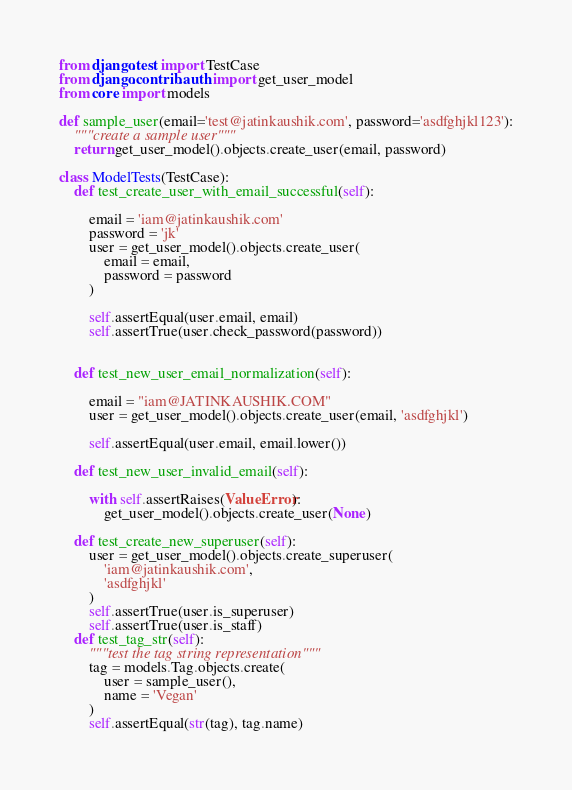<code> <loc_0><loc_0><loc_500><loc_500><_Python_>from django.test import TestCase
from django.contrib.auth import get_user_model
from core import models

def sample_user(email='test@jatinkaushik.com', password='asdfghjkl123'):
    """create a sample user"""
    return get_user_model().objects.create_user(email, password)

class ModelTests(TestCase):
    def test_create_user_with_email_successful(self):

        email = 'iam@jatinkaushik.com'
        password = 'jk'
        user = get_user_model().objects.create_user(
            email = email,
            password = password
        )

        self.assertEqual(user.email, email)
        self.assertTrue(user.check_password(password))


    def test_new_user_email_normalization(self):

        email = "iam@JATINKAUSHIK.COM"
        user = get_user_model().objects.create_user(email, 'asdfghjkl')

        self.assertEqual(user.email, email.lower())

    def test_new_user_invalid_email(self):

        with self.assertRaises(ValueError):
            get_user_model().objects.create_user(None)

    def test_create_new_superuser(self):
        user = get_user_model().objects.create_superuser(
            'iam@jatinkaushik.com',
            'asdfghjkl'
        )
        self.assertTrue(user.is_superuser)
        self.assertTrue(user.is_staff)
    def test_tag_str(self):
        """test the tag string representation"""
        tag = models.Tag.objects.create(
            user = sample_user(),
            name = 'Vegan'
        )
        self.assertEqual(str(tag), tag.name)</code> 